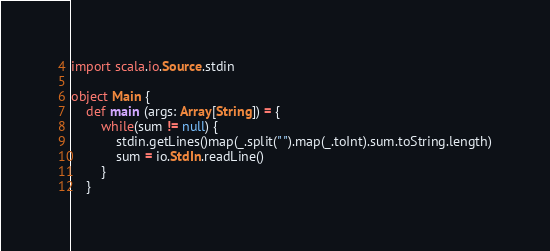<code> <loc_0><loc_0><loc_500><loc_500><_Scala_>import scala.io.Source.stdin

object Main {
	def main (args: Array[String]) = {
		while(sum != null) {
			stdin.getLines()map(_.split(" ").map(_.toInt).sum.toString.length)
			sum = io.StdIn.readLine()
		}
	}</code> 